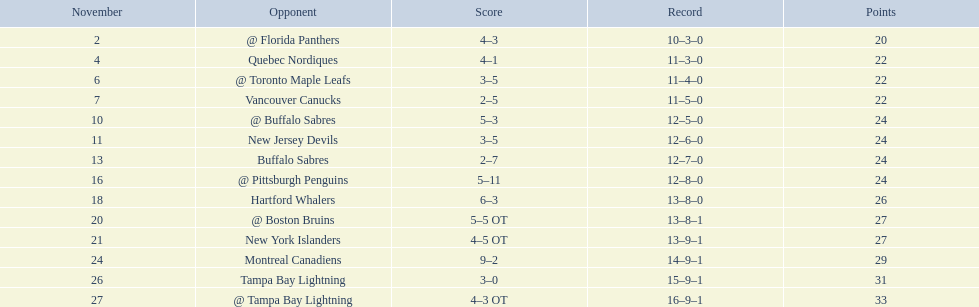Who are all of the teams? @ Florida Panthers, Quebec Nordiques, @ Toronto Maple Leafs, Vancouver Canucks, @ Buffalo Sabres, New Jersey Devils, Buffalo Sabres, @ Pittsburgh Penguins, Hartford Whalers, @ Boston Bruins, New York Islanders, Montreal Canadiens, Tampa Bay Lightning. What games finished in overtime? 22, 23, 26. In game number 23, who did they face? New York Islanders. Can you give me this table as a dict? {'header': ['November', 'Opponent', 'Score', 'Record', 'Points'], 'rows': [['2', '@ Florida Panthers', '4–3', '10–3–0', '20'], ['4', 'Quebec Nordiques', '4–1', '11–3–0', '22'], ['6', '@ Toronto Maple Leafs', '3–5', '11–4–0', '22'], ['7', 'Vancouver Canucks', '2–5', '11–5–0', '22'], ['10', '@ Buffalo Sabres', '5–3', '12–5–0', '24'], ['11', 'New Jersey Devils', '3–5', '12–6–0', '24'], ['13', 'Buffalo Sabres', '2–7', '12–7–0', '24'], ['16', '@ Pittsburgh Penguins', '5–11', '12–8–0', '24'], ['18', 'Hartford Whalers', '6–3', '13–8–0', '26'], ['20', '@ Boston Bruins', '5–5 OT', '13–8–1', '27'], ['21', 'New York Islanders', '4–5 OT', '13–9–1', '27'], ['24', 'Montreal Canadiens', '9–2', '14–9–1', '29'], ['26', 'Tampa Bay Lightning', '3–0', '15–9–1', '31'], ['27', '@ Tampa Bay Lightning', '4–3 OT', '16–9–1', '33']]} 